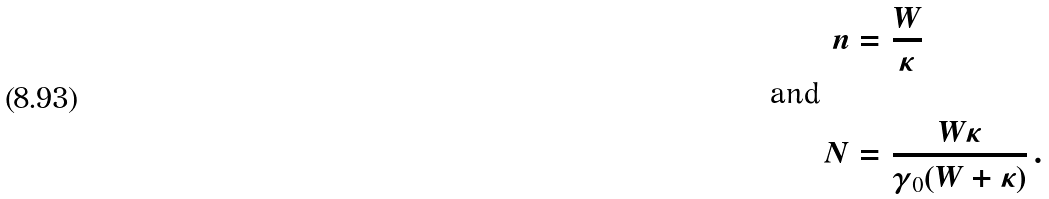Convert formula to latex. <formula><loc_0><loc_0><loc_500><loc_500>n & = \frac { W } { \kappa } \\ \text {and} \quad & \\ N & = \frac { W \kappa } { \gamma _ { 0 } ( W + \kappa ) } \, .</formula> 